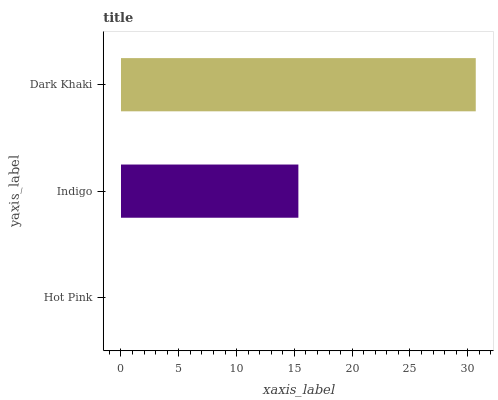Is Hot Pink the minimum?
Answer yes or no. Yes. Is Dark Khaki the maximum?
Answer yes or no. Yes. Is Indigo the minimum?
Answer yes or no. No. Is Indigo the maximum?
Answer yes or no. No. Is Indigo greater than Hot Pink?
Answer yes or no. Yes. Is Hot Pink less than Indigo?
Answer yes or no. Yes. Is Hot Pink greater than Indigo?
Answer yes or no. No. Is Indigo less than Hot Pink?
Answer yes or no. No. Is Indigo the high median?
Answer yes or no. Yes. Is Indigo the low median?
Answer yes or no. Yes. Is Dark Khaki the high median?
Answer yes or no. No. Is Hot Pink the low median?
Answer yes or no. No. 